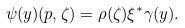<formula> <loc_0><loc_0><loc_500><loc_500>\psi ( y ) ( p , \zeta ) = \rho ( \zeta ) \xi ^ { * } \gamma ( y ) .</formula> 